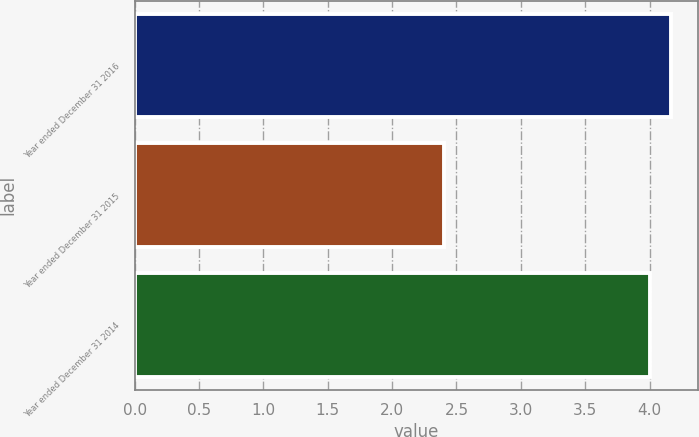<chart> <loc_0><loc_0><loc_500><loc_500><bar_chart><fcel>Year ended December 31 2016<fcel>Year ended December 31 2015<fcel>Year ended December 31 2014<nl><fcel>4.17<fcel>2.4<fcel>4<nl></chart> 